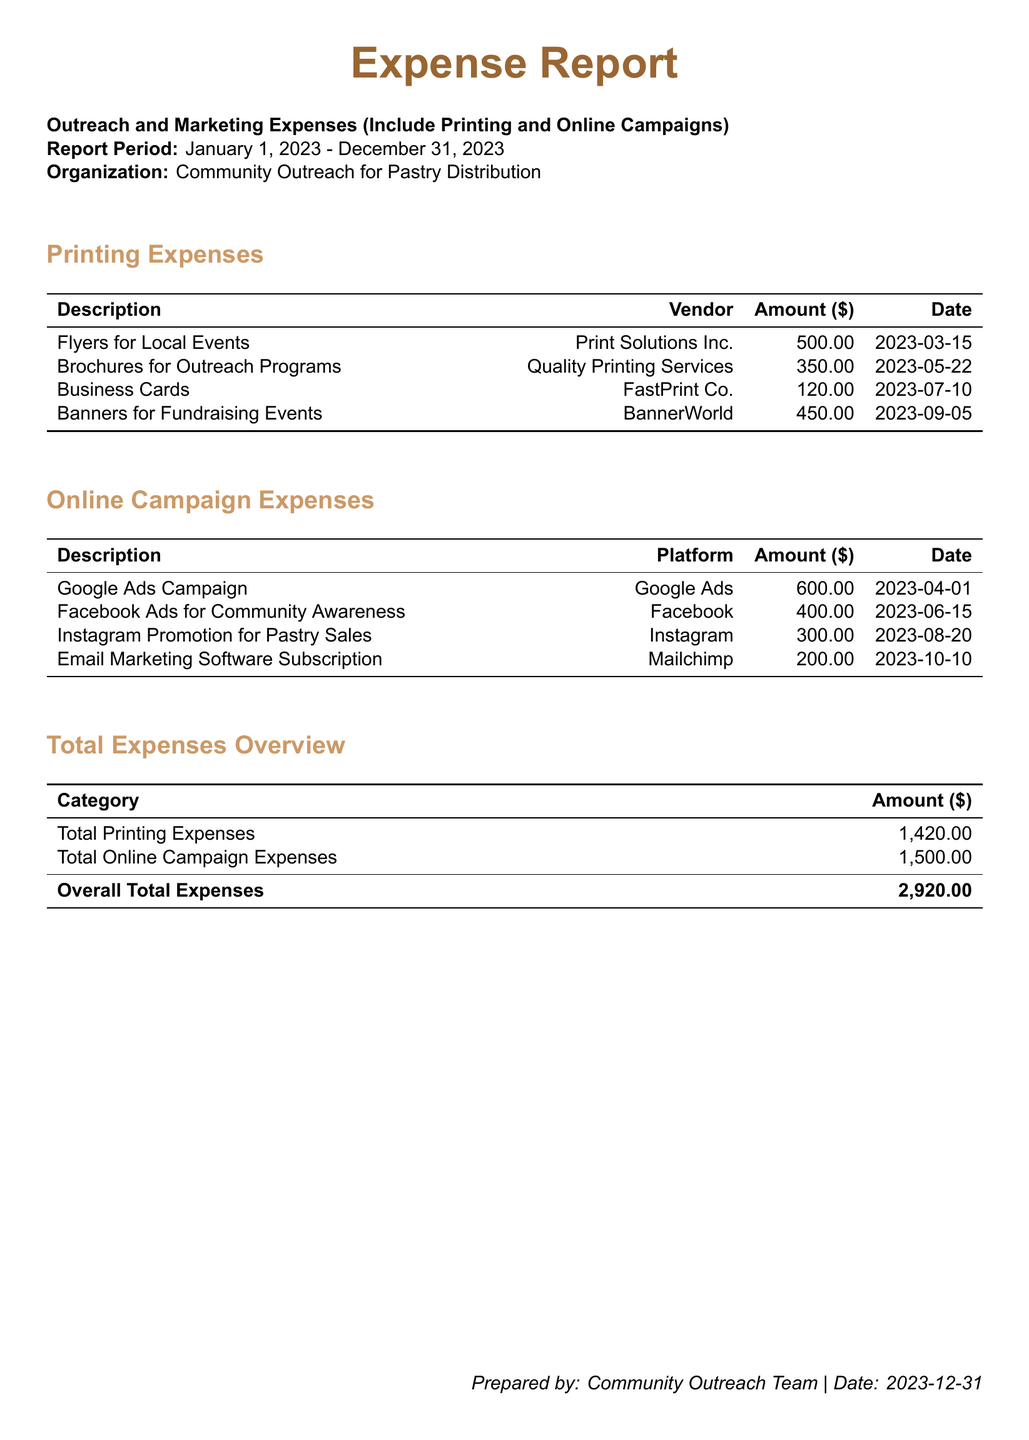what was the total amount spent on printing? The total amount spent on printing is listed under Total Printing Expenses in the document.
Answer: 1,420.00 what is the total amount spent on online campaigns? The total amount spent on online campaigns is found in the Total Online Campaign Expenses section.
Answer: 1,500.00 who provided the flyers for local events? The vendor for the flyers is mentioned in the Printing Expenses section.
Answer: Print Solutions Inc when were the brochures for outreach programs printed? The date the brochures were printed is listed in the Printing Expenses section.
Answer: 2023-05-22 how much was spent on Google Ads Campaign? The amount spent on the Google Ads Campaign is specified in the Online Campaign Expenses section.
Answer: 600.00 what is the overall total expenses for the year? The overall total expenses can be found in the Total Expenses Overview section.
Answer: 2,920.00 which platform was used for Instagram Promotion for Pastry Sales? The platform used for the Instagram Promotion is indicated in the Online Campaign Expenses section.
Answer: Instagram how many distinct printing expenses are listed? The number of distinct printing expenses can be counted from the Printing Expenses table.
Answer: 4 what date was the email marketing software subscription made? The date of the email marketing software subscription is stated in the Online Campaign Expenses section.
Answer: 2023-10-10 